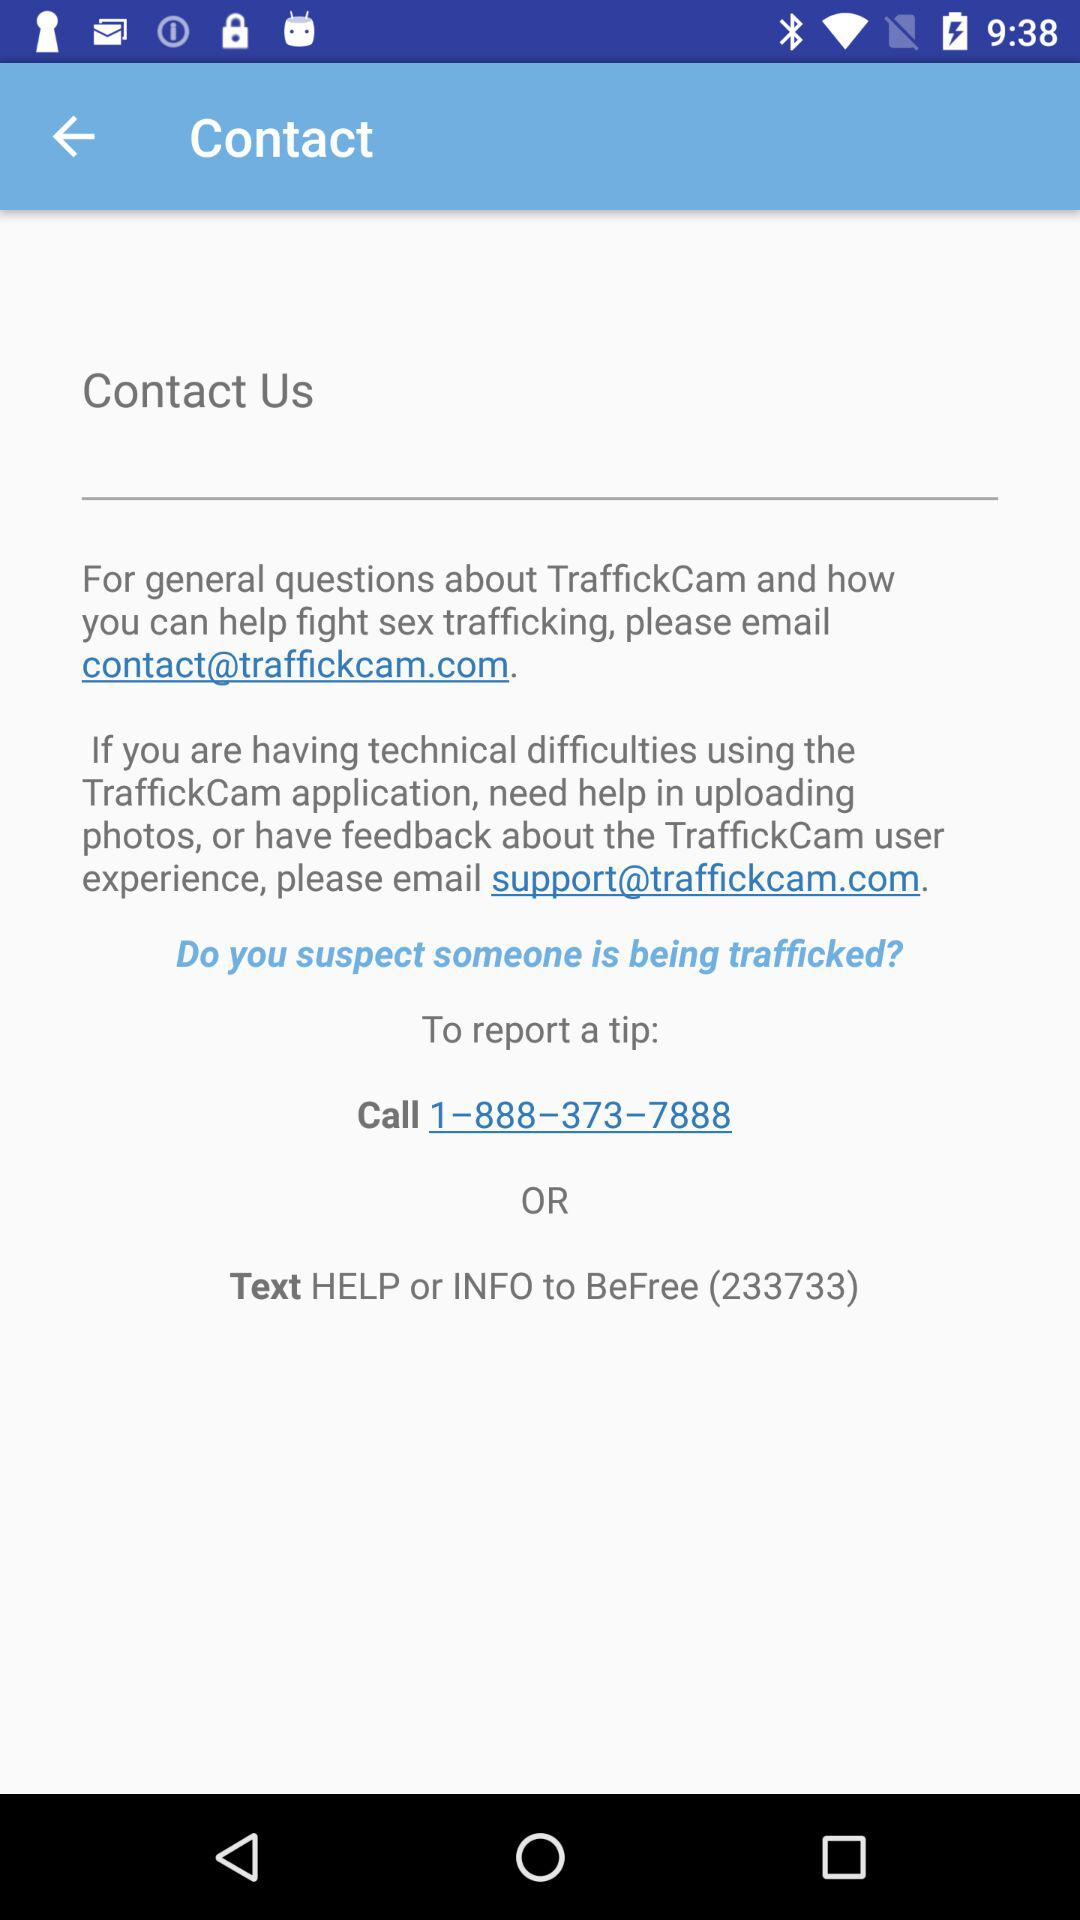What is the email address for contact? The email address is contact@traffickcam.com. 